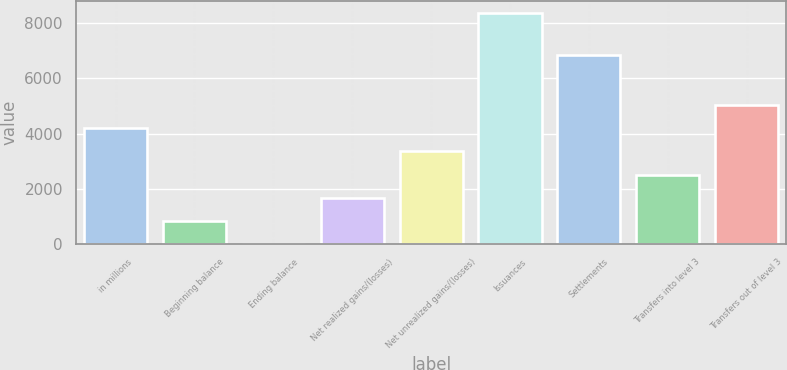<chart> <loc_0><loc_0><loc_500><loc_500><bar_chart><fcel>in millions<fcel>Beginning balance<fcel>Ending balance<fcel>Net realized gains/(losses)<fcel>Net unrealized gains/(losses)<fcel>Issuances<fcel>Settlements<fcel>Transfers into level 3<fcel>Transfers out of level 3<nl><fcel>4193<fcel>841.8<fcel>4<fcel>1679.6<fcel>3355.2<fcel>8382<fcel>6859<fcel>2517.4<fcel>5030.8<nl></chart> 